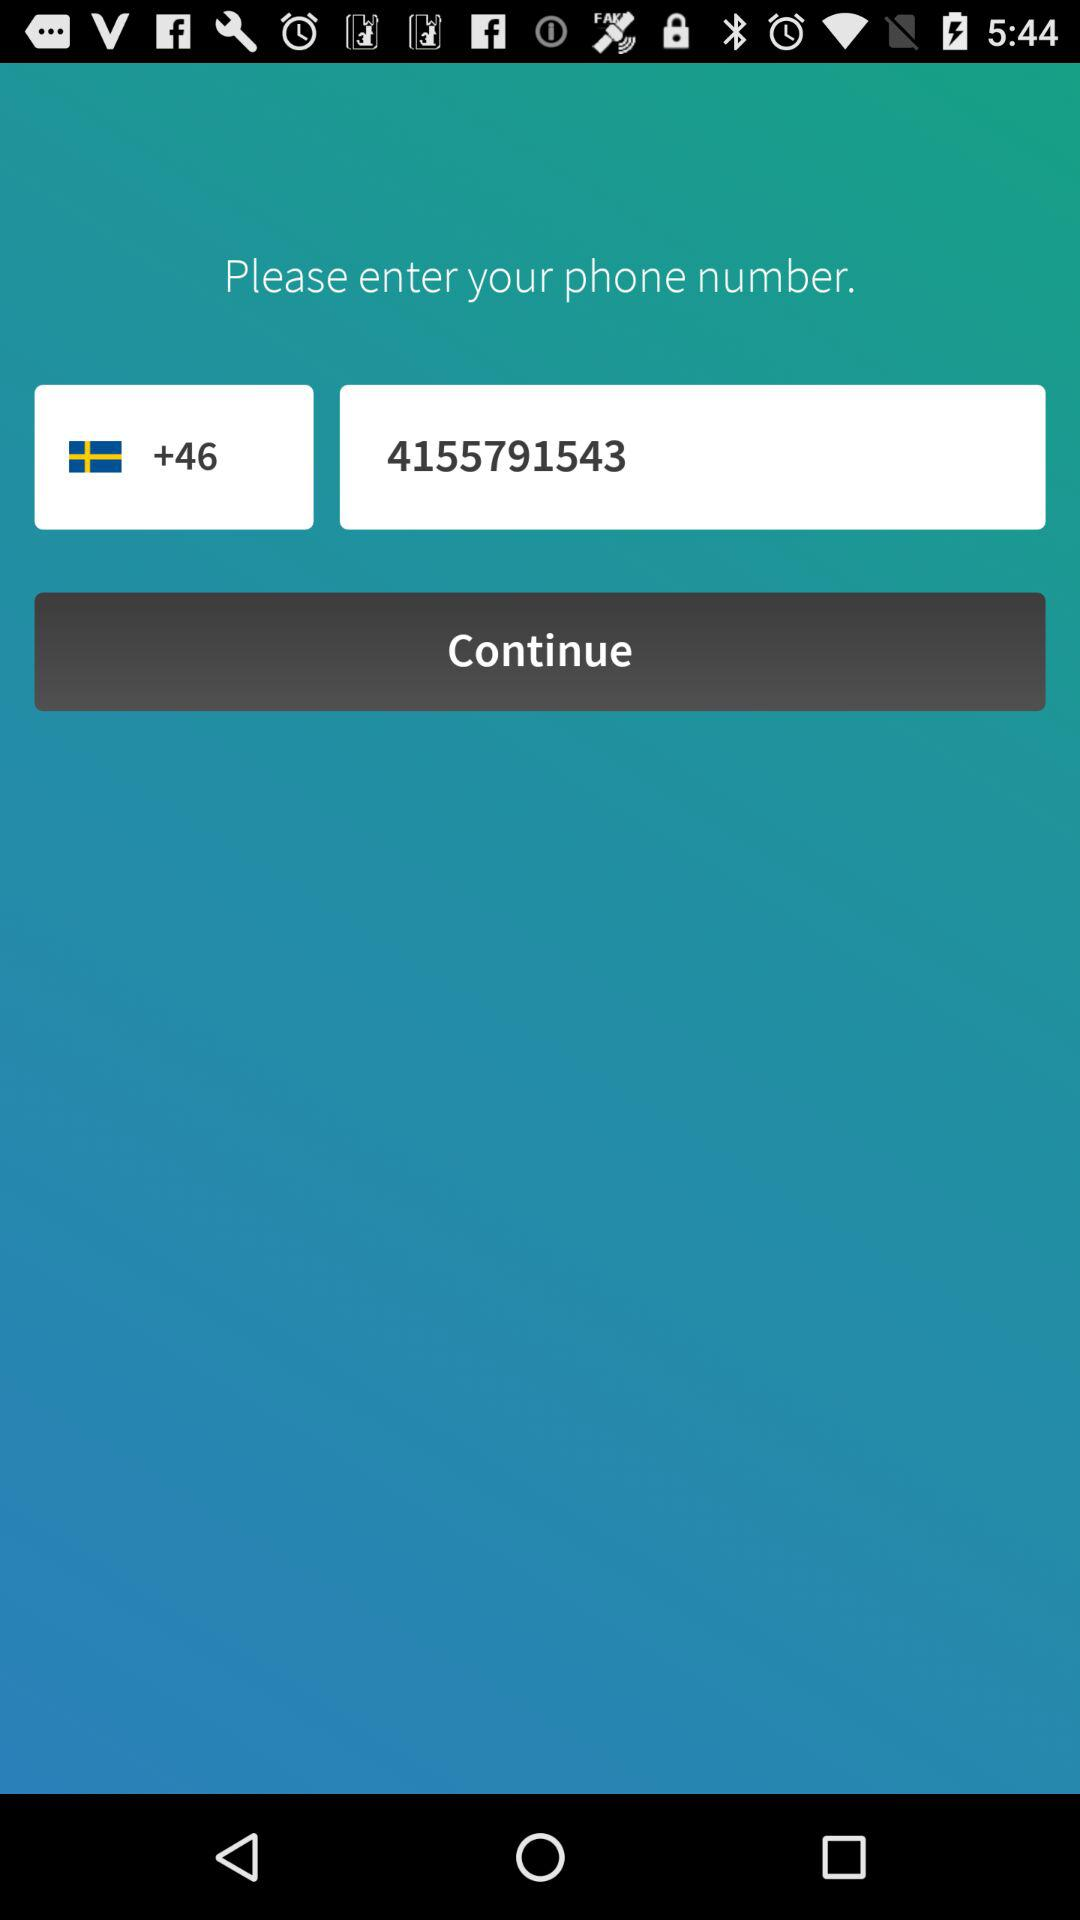How many digits are in the phone number in the first text input?
Answer the question using a single word or phrase. 10 